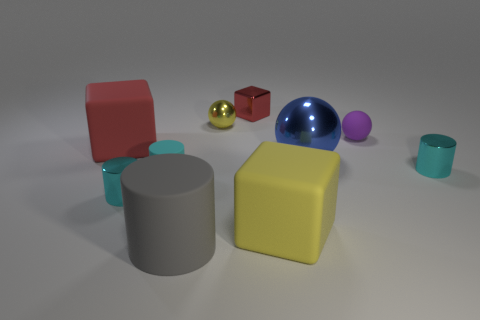Is there a purple sphere of the same size as the yellow matte thing?
Make the answer very short. No. Does the tiny purple matte object that is right of the tiny shiny block have the same shape as the big red rubber object?
Your response must be concise. No. What is the color of the large metal sphere?
Your answer should be compact. Blue. The rubber thing that is the same color as the small cube is what shape?
Make the answer very short. Cube. Are there any large cyan matte cylinders?
Keep it short and to the point. No. Are there an equal number of cyan rubber cylinders and big cyan shiny cubes?
Your answer should be very brief. No. There is a cyan cylinder that is the same material as the purple object; what is its size?
Your answer should be very brief. Small. The yellow thing that is in front of the rubber cube that is behind the small cylinder right of the gray rubber cylinder is what shape?
Your answer should be compact. Cube. Are there the same number of purple matte balls left of the yellow metal object and purple rubber spheres?
Provide a short and direct response. No. There is a matte cube that is the same color as the small shiny block; what is its size?
Provide a short and direct response. Large. 